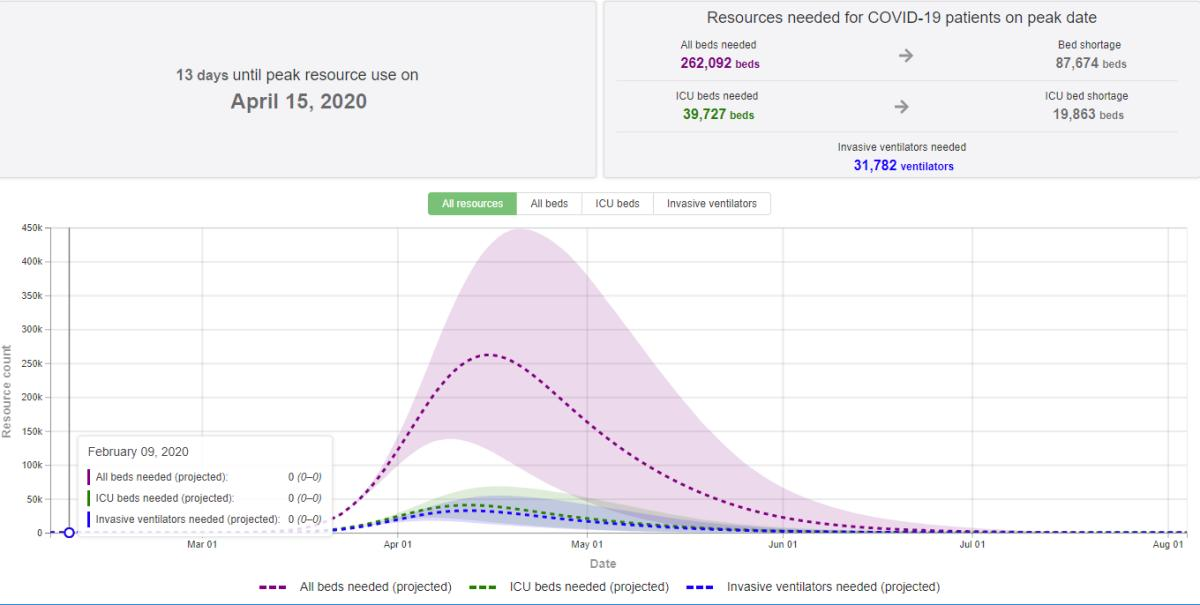Draw attention to some important aspects in this diagram. A total of 31,782 invasive ventilators are needed. The number of ICU beds required is 39,727. 